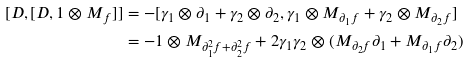<formula> <loc_0><loc_0><loc_500><loc_500>[ D , [ D , 1 \otimes M _ { f } ] ] & = - [ \gamma _ { 1 } \otimes \partial _ { 1 } + \gamma _ { 2 } \otimes \partial _ { 2 } , \gamma _ { 1 } \otimes M _ { \partial _ { 1 } f } + \gamma _ { 2 } \otimes M _ { \partial _ { 2 } f } ] \\ & = - 1 \otimes M _ { \partial _ { 1 } ^ { 2 } f + \partial _ { 2 } ^ { 2 } f } + 2 \gamma _ { 1 } \gamma _ { 2 } \otimes ( M _ { \partial _ { 2 } f } \partial _ { 1 } + M _ { \partial _ { 1 } f } \partial _ { 2 } )</formula> 